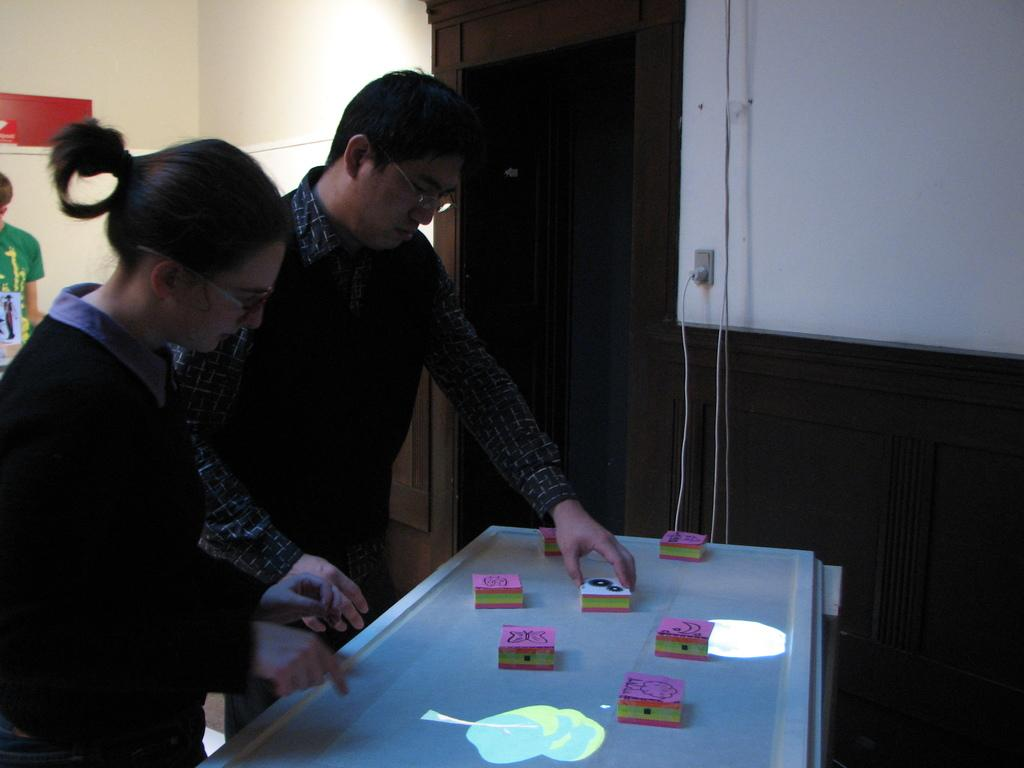Who is present in the image? There is a woman and a man in the image. What are the woman and man doing in the image? The woman and man are holding something in the image. Where are the objects they are holding located? The objects they are holding are on a table. Can you describe the background of the image? There is another person standing in the background, and there is a door on the right side of the image. What type of fowl can be seen playing on the playground in the image? There is no playground or fowl present in the image. 